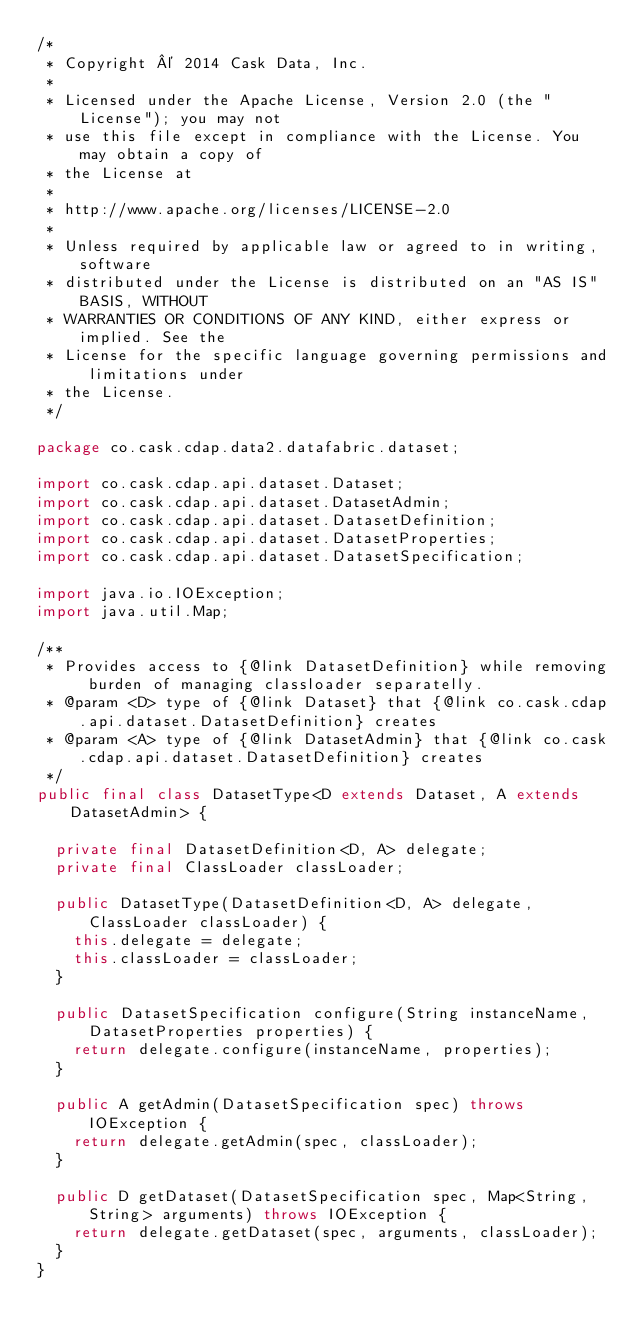<code> <loc_0><loc_0><loc_500><loc_500><_Java_>/*
 * Copyright © 2014 Cask Data, Inc.
 *
 * Licensed under the Apache License, Version 2.0 (the "License"); you may not
 * use this file except in compliance with the License. You may obtain a copy of
 * the License at
 *
 * http://www.apache.org/licenses/LICENSE-2.0
 *
 * Unless required by applicable law or agreed to in writing, software
 * distributed under the License is distributed on an "AS IS" BASIS, WITHOUT
 * WARRANTIES OR CONDITIONS OF ANY KIND, either express or implied. See the
 * License for the specific language governing permissions and limitations under
 * the License.
 */

package co.cask.cdap.data2.datafabric.dataset;

import co.cask.cdap.api.dataset.Dataset;
import co.cask.cdap.api.dataset.DatasetAdmin;
import co.cask.cdap.api.dataset.DatasetDefinition;
import co.cask.cdap.api.dataset.DatasetProperties;
import co.cask.cdap.api.dataset.DatasetSpecification;

import java.io.IOException;
import java.util.Map;

/**
 * Provides access to {@link DatasetDefinition} while removing burden of managing classloader separatelly.
 * @param <D> type of {@link Dataset} that {@link co.cask.cdap.api.dataset.DatasetDefinition} creates
 * @param <A> type of {@link DatasetAdmin} that {@link co.cask.cdap.api.dataset.DatasetDefinition} creates
 */
public final class DatasetType<D extends Dataset, A extends DatasetAdmin> {

  private final DatasetDefinition<D, A> delegate;
  private final ClassLoader classLoader;

  public DatasetType(DatasetDefinition<D, A> delegate, ClassLoader classLoader) {
    this.delegate = delegate;
    this.classLoader = classLoader;
  }

  public DatasetSpecification configure(String instanceName, DatasetProperties properties) {
    return delegate.configure(instanceName, properties);
  }

  public A getAdmin(DatasetSpecification spec) throws IOException {
    return delegate.getAdmin(spec, classLoader);
  }

  public D getDataset(DatasetSpecification spec, Map<String, String> arguments) throws IOException {
    return delegate.getDataset(spec, arguments, classLoader);
  }
}
</code> 